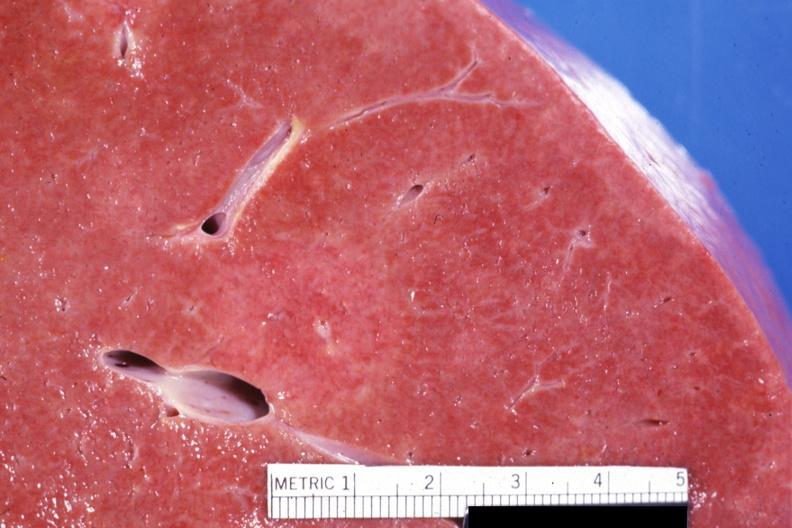what are visible?
Answer the question using a single word or phrase. This close-up of cut surface infiltrates 